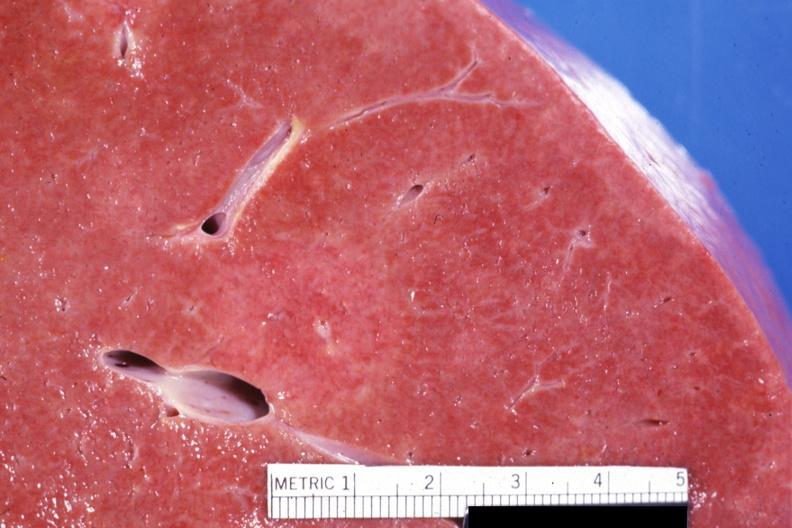what are visible?
Answer the question using a single word or phrase. This close-up of cut surface infiltrates 